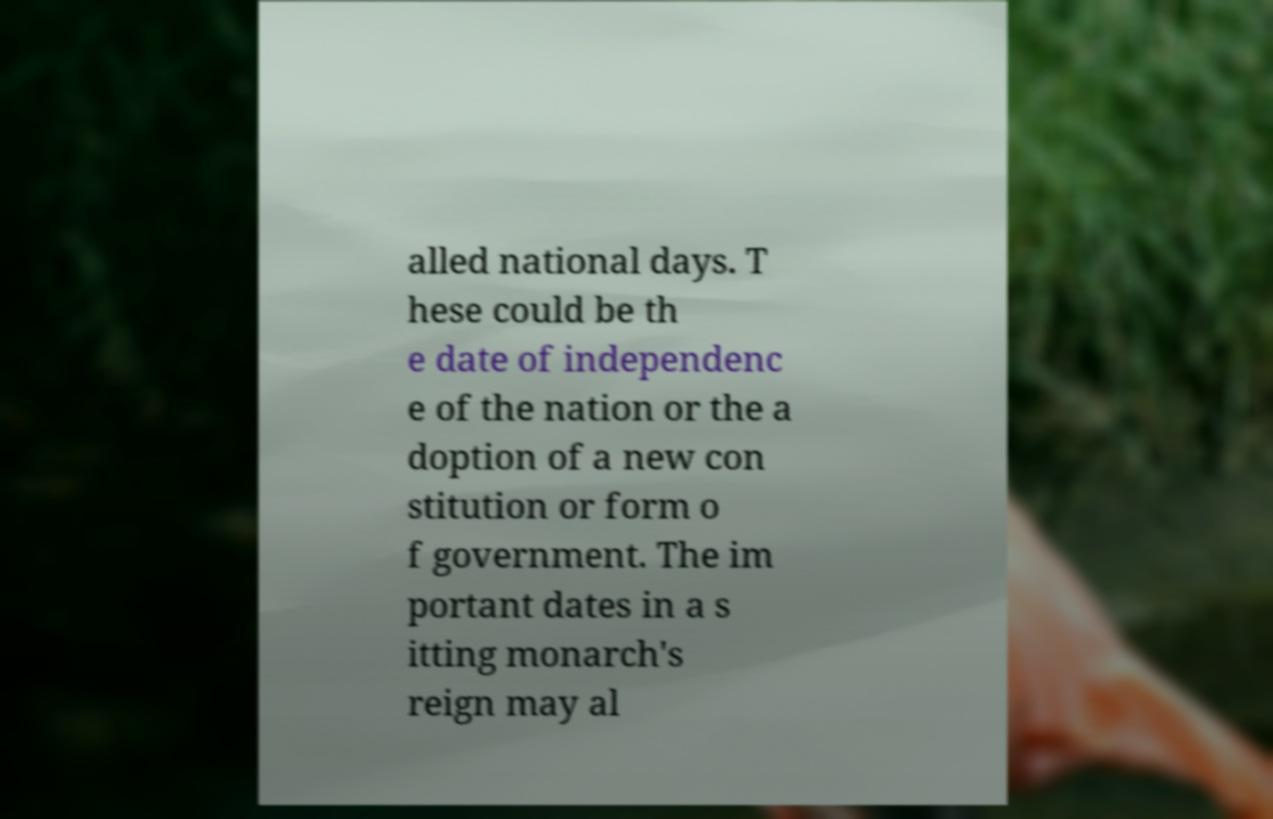Can you accurately transcribe the text from the provided image for me? alled national days. T hese could be th e date of independenc e of the nation or the a doption of a new con stitution or form o f government. The im portant dates in a s itting monarch's reign may al 